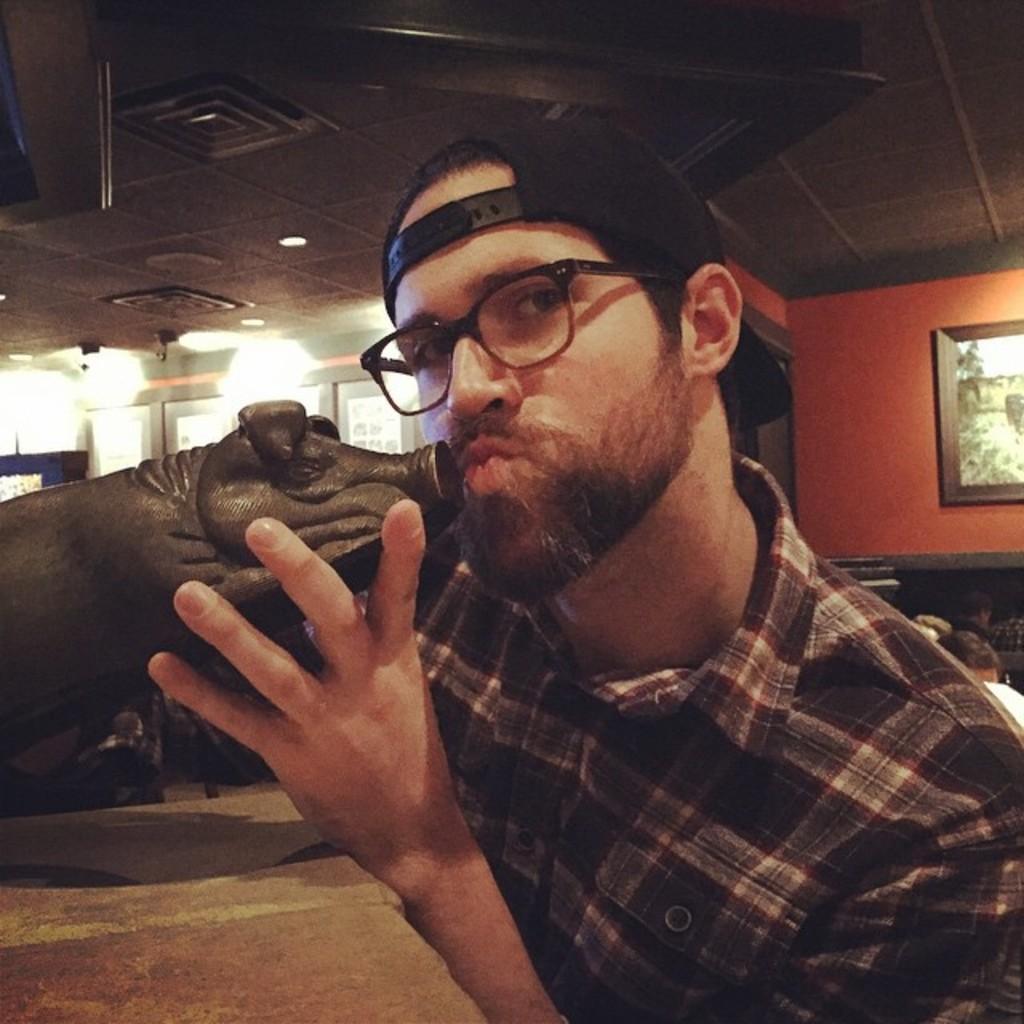Describe this image in one or two sentences. In this picture I can see a man holding a toy pig in his hand and he wore a cap and spectacles and I can see a photo frame on the wall and few people seated on the back and I can see a table and few lights. 